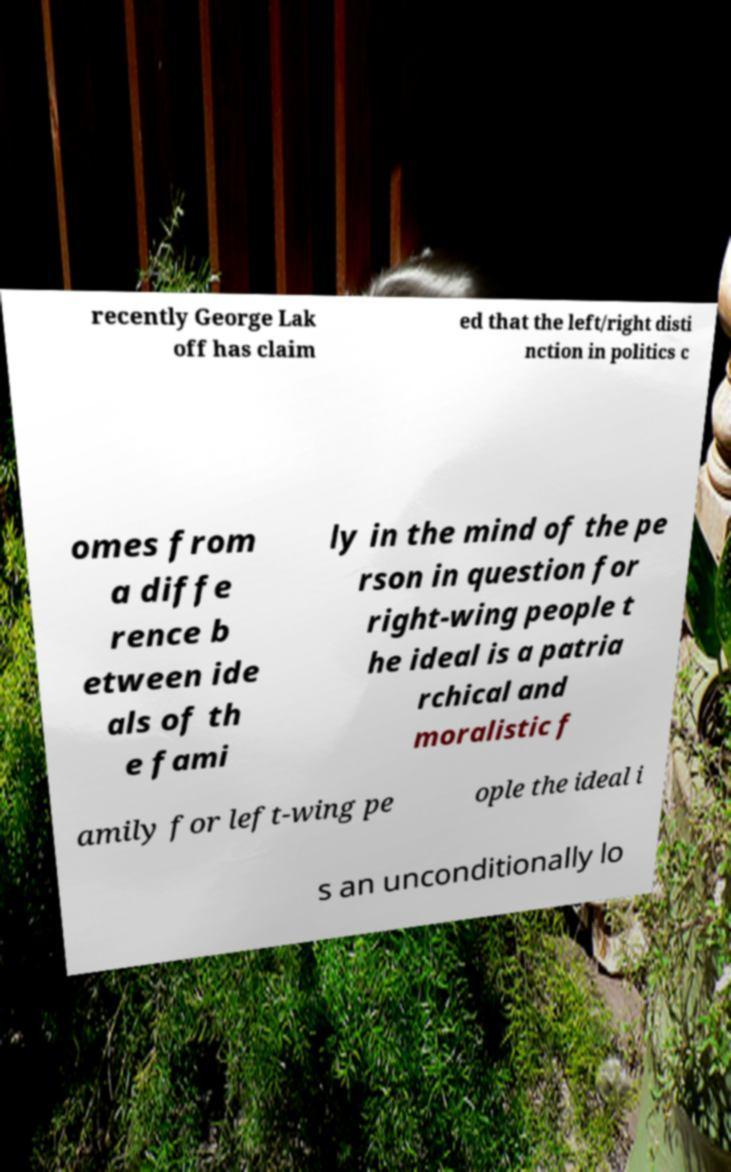There's text embedded in this image that I need extracted. Can you transcribe it verbatim? recently George Lak off has claim ed that the left/right disti nction in politics c omes from a diffe rence b etween ide als of th e fami ly in the mind of the pe rson in question for right-wing people t he ideal is a patria rchical and moralistic f amily for left-wing pe ople the ideal i s an unconditionally lo 